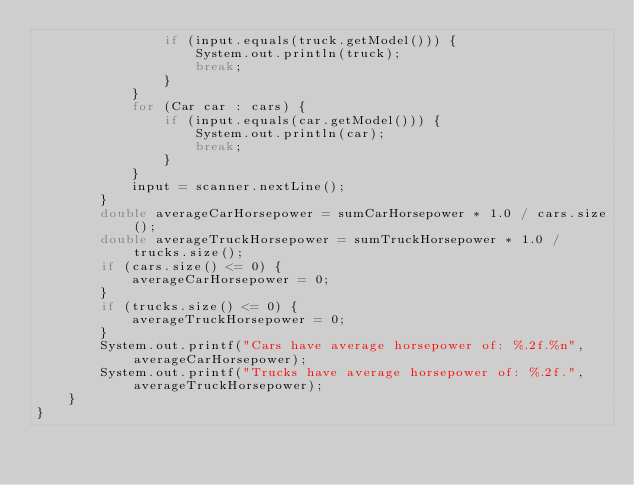Convert code to text. <code><loc_0><loc_0><loc_500><loc_500><_Java_>                if (input.equals(truck.getModel())) {
                    System.out.println(truck);
                    break;
                }
            }
            for (Car car : cars) {
                if (input.equals(car.getModel())) {
                    System.out.println(car);
                    break;
                }
            }
            input = scanner.nextLine();
        }
        double averageCarHorsepower = sumCarHorsepower * 1.0 / cars.size();
        double averageTruckHorsepower = sumTruckHorsepower * 1.0 / trucks.size();
        if (cars.size() <= 0) {
            averageCarHorsepower = 0;
        }
        if (trucks.size() <= 0) {
            averageTruckHorsepower = 0;
        }
        System.out.printf("Cars have average horsepower of: %.2f.%n", averageCarHorsepower);
        System.out.printf("Trucks have average horsepower of: %.2f.", averageTruckHorsepower);
    }
}
</code> 